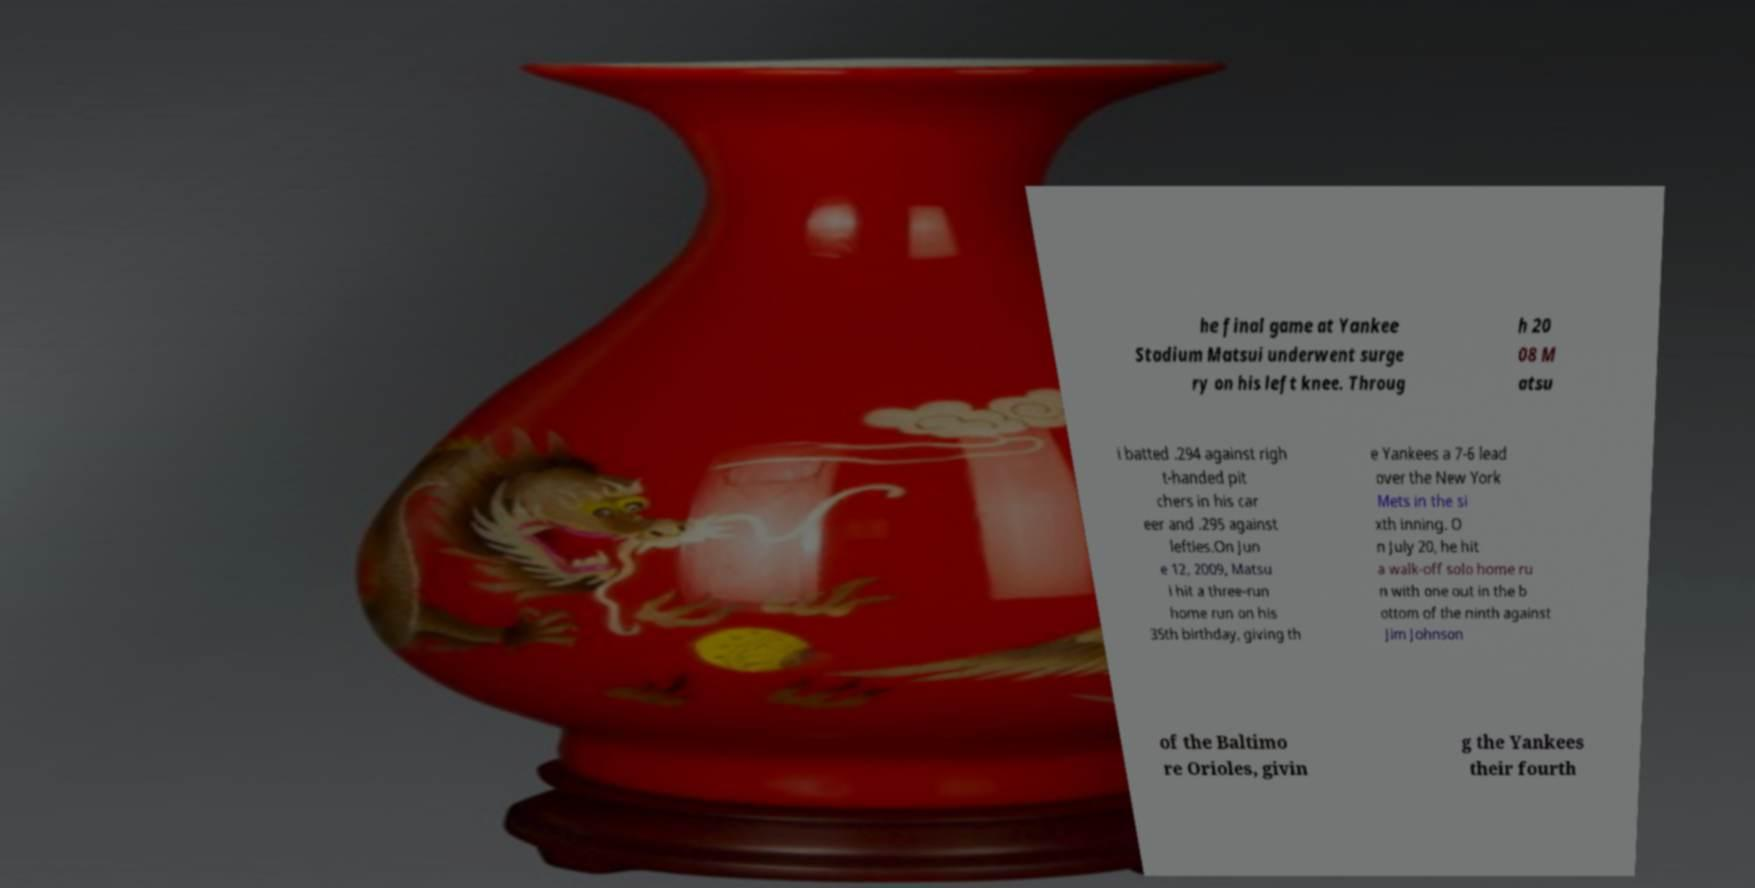Could you assist in decoding the text presented in this image and type it out clearly? he final game at Yankee Stadium Matsui underwent surge ry on his left knee. Throug h 20 08 M atsu i batted .294 against righ t-handed pit chers in his car eer and .295 against lefties.On Jun e 12, 2009, Matsu i hit a three-run home run on his 35th birthday, giving th e Yankees a 7-6 lead over the New York Mets in the si xth inning. O n July 20, he hit a walk-off solo home ru n with one out in the b ottom of the ninth against Jim Johnson of the Baltimo re Orioles, givin g the Yankees their fourth 